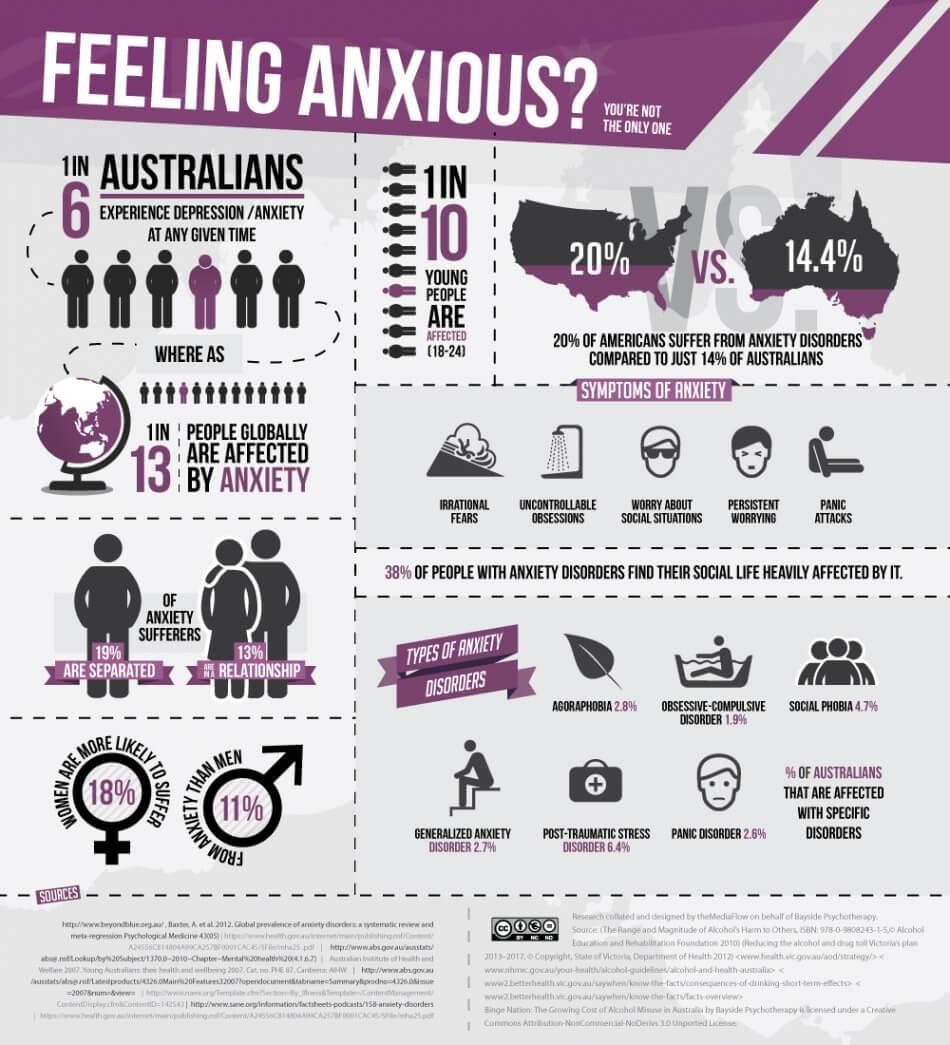What percentage of Australians are affected with Agoraphobia?
Answer the question with a short phrase. 2.8% What percentage of anxiety sufferers in Australia are in a relationship? 13% What percentage of Australians suffer from anxiety disorders? 14% What percentage of Americans do not suffer from anxiety disorders? 80% Which type of anxiety disorders is most dominant among the Australians? POST-TRAUMATIC STRESS DISORDER Which type of anxiety disorders is least affected in the Australians? OBSESSIVE-COMPULSIVE DISORDER What percentage of Australians are affected with panic disorder? 2.6% What percentage of men in Australia are more likely to suffer from anxiety? 11% What percentage of women in Australia are more likely to suffer from anxiety? 18% 